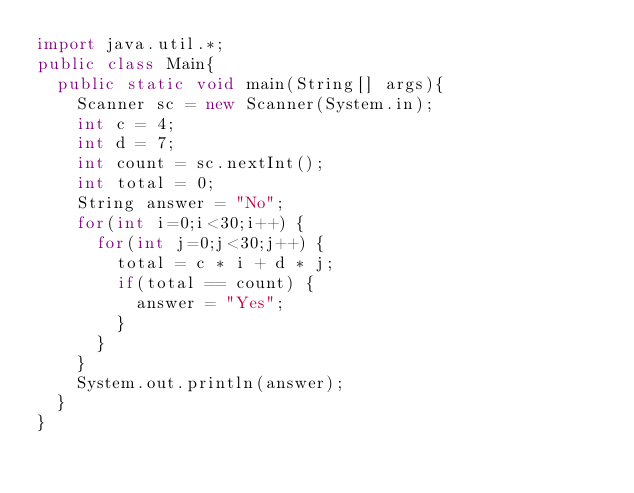Convert code to text. <code><loc_0><loc_0><loc_500><loc_500><_Java_>import java.util.*;
public class Main{
  public static void main(String[] args){
    Scanner sc = new Scanner(System.in);
    int c = 4;
    int d = 7;
    int count = sc.nextInt();
    int total = 0;
    String answer = "No";
    for(int i=0;i<30;i++) {
      for(int j=0;j<30;j++) {
      	total = c * i + d * j;
        if(total == count) {
          answer = "Yes";
        }
      }
  	}
    System.out.println(answer);
  }
}</code> 